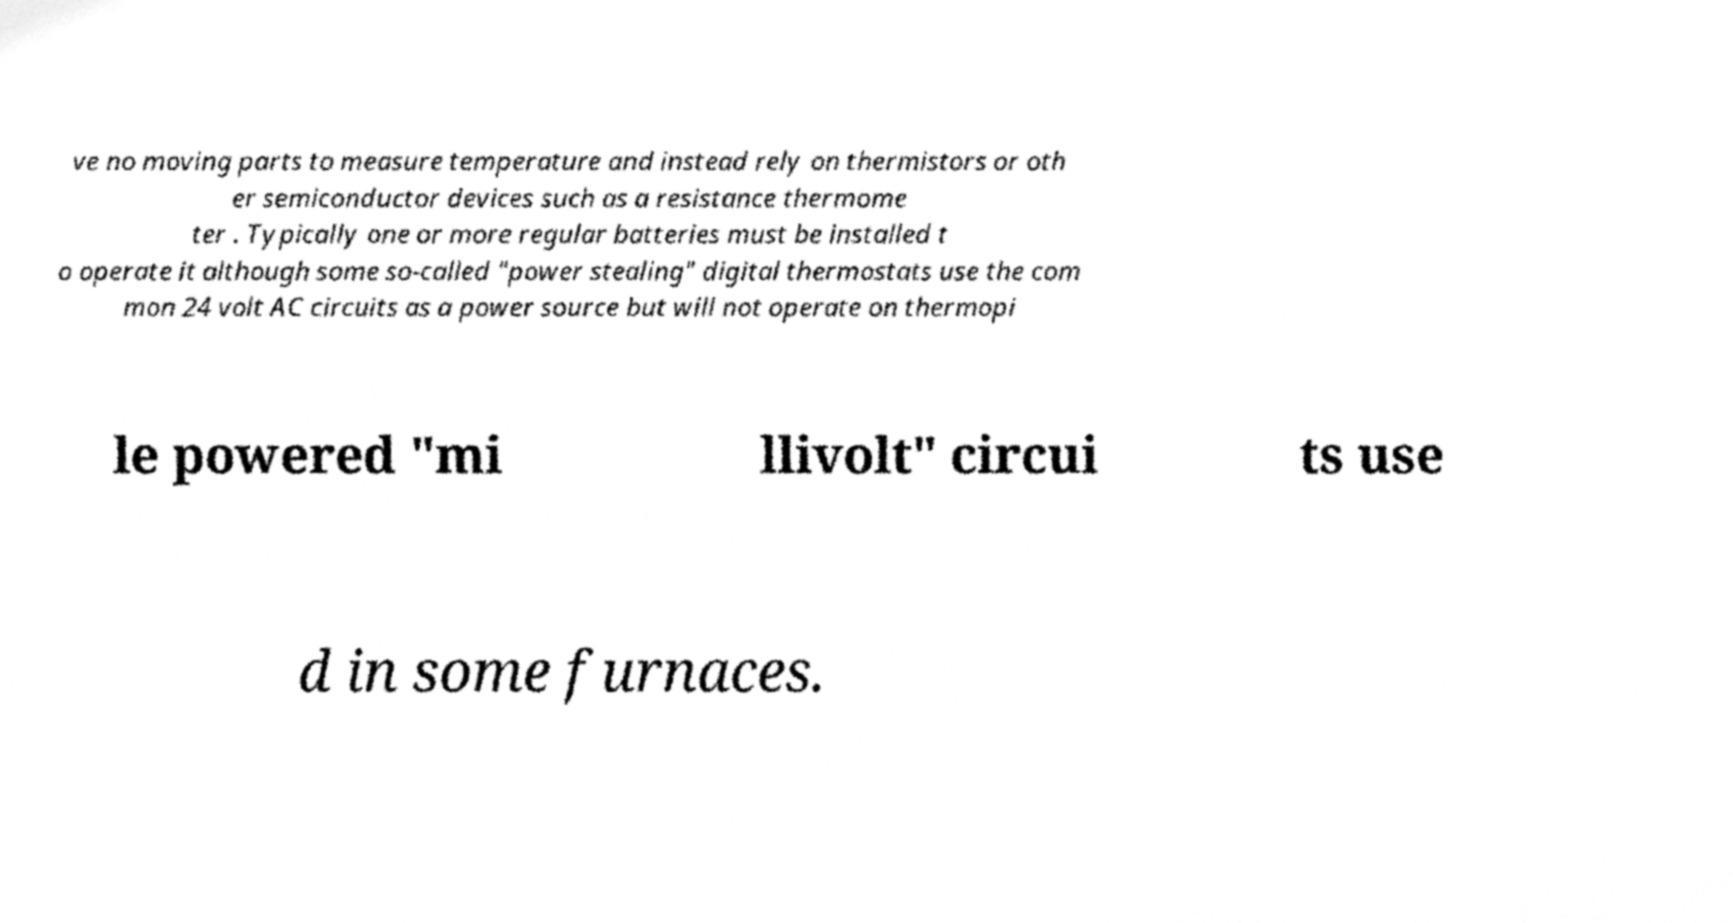What messages or text are displayed in this image? I need them in a readable, typed format. ve no moving parts to measure temperature and instead rely on thermistors or oth er semiconductor devices such as a resistance thermome ter . Typically one or more regular batteries must be installed t o operate it although some so-called "power stealing" digital thermostats use the com mon 24 volt AC circuits as a power source but will not operate on thermopi le powered "mi llivolt" circui ts use d in some furnaces. 